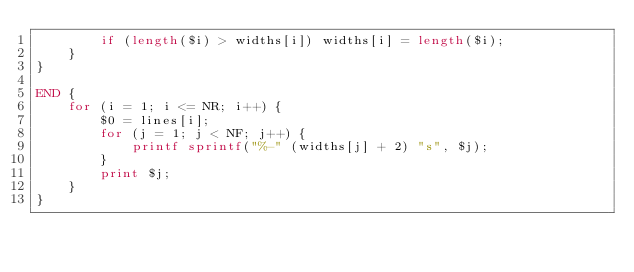<code> <loc_0><loc_0><loc_500><loc_500><_Awk_>        if (length($i) > widths[i]) widths[i] = length($i);
    }
}

END {
    for (i = 1; i <= NR; i++) {
        $0 = lines[i];
        for (j = 1; j < NF; j++) {
            printf sprintf("%-" (widths[j] + 2) "s", $j);
        }
        print $j;
    }
}
</code> 